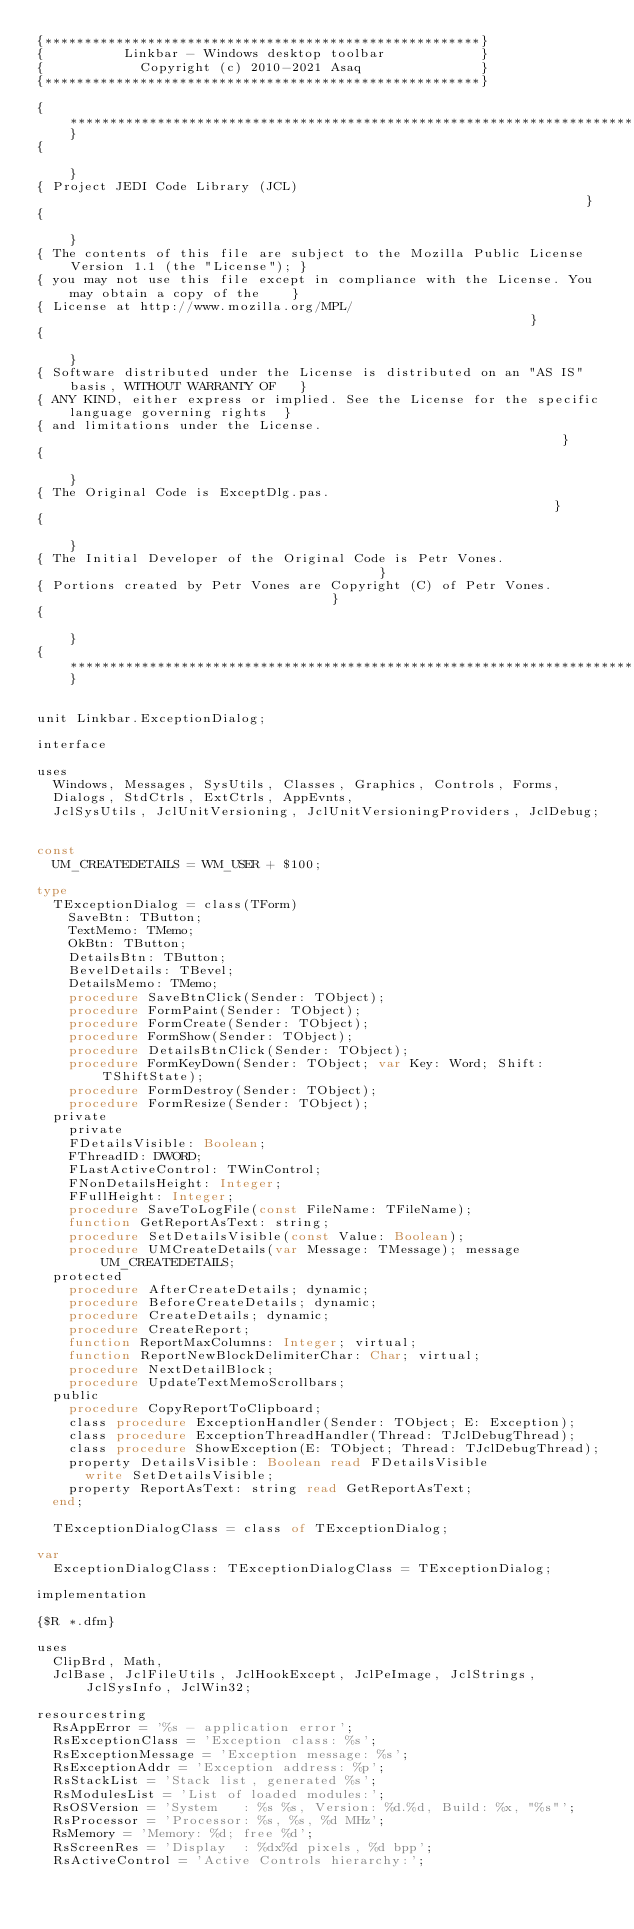<code> <loc_0><loc_0><loc_500><loc_500><_Pascal_>{*******************************************************}
{          Linkbar - Windows desktop toolbar            }
{            Copyright (c) 2010-2021 Asaq               }
{*******************************************************}

{**************************************************************************************************}
{                                                                                                  }
{ Project JEDI Code Library (JCL)                                                                  }
{                                                                                                  }
{ The contents of this file are subject to the Mozilla Public License Version 1.1 (the "License"); }
{ you may not use this file except in compliance with the License. You may obtain a copy of the    }
{ License at http://www.mozilla.org/MPL/                                                           }
{                                                                                                  }
{ Software distributed under the License is distributed on an "AS IS" basis, WITHOUT WARRANTY OF   }
{ ANY KIND, either express or implied. See the License for the specific language governing rights  }
{ and limitations under the License.                                                               }
{                                                                                                  }
{ The Original Code is ExceptDlg.pas.                                                              }
{                                                                                                  }
{ The Initial Developer of the Original Code is Petr Vones.                                        }
{ Portions created by Petr Vones are Copyright (C) of Petr Vones.                                  }
{                                                                                                  }
{**************************************************************************************************}


unit Linkbar.ExceptionDialog;

interface

uses
  Windows, Messages, SysUtils, Classes, Graphics, Controls, Forms,
  Dialogs, StdCtrls, ExtCtrls, AppEvnts,
  JclSysUtils, JclUnitVersioning, JclUnitVersioningProviders, JclDebug;


const
  UM_CREATEDETAILS = WM_USER + $100;

type
  TExceptionDialog = class(TForm)
    SaveBtn: TButton;
    TextMemo: TMemo;
    OkBtn: TButton;
    DetailsBtn: TButton;
    BevelDetails: TBevel;
    DetailsMemo: TMemo;
    procedure SaveBtnClick(Sender: TObject);
    procedure FormPaint(Sender: TObject);
    procedure FormCreate(Sender: TObject);
    procedure FormShow(Sender: TObject);
    procedure DetailsBtnClick(Sender: TObject);
    procedure FormKeyDown(Sender: TObject; var Key: Word; Shift: TShiftState);
    procedure FormDestroy(Sender: TObject);
    procedure FormResize(Sender: TObject);
  private
    private
    FDetailsVisible: Boolean;
    FThreadID: DWORD;
    FLastActiveControl: TWinControl;
    FNonDetailsHeight: Integer;
    FFullHeight: Integer;
    procedure SaveToLogFile(const FileName: TFileName);
    function GetReportAsText: string;
    procedure SetDetailsVisible(const Value: Boolean);
    procedure UMCreateDetails(var Message: TMessage); message UM_CREATEDETAILS;
  protected
    procedure AfterCreateDetails; dynamic;
    procedure BeforeCreateDetails; dynamic;
    procedure CreateDetails; dynamic;
    procedure CreateReport;
    function ReportMaxColumns: Integer; virtual;
    function ReportNewBlockDelimiterChar: Char; virtual;
    procedure NextDetailBlock;
    procedure UpdateTextMemoScrollbars;
  public
    procedure CopyReportToClipboard;
    class procedure ExceptionHandler(Sender: TObject; E: Exception);
    class procedure ExceptionThreadHandler(Thread: TJclDebugThread);
    class procedure ShowException(E: TObject; Thread: TJclDebugThread);
    property DetailsVisible: Boolean read FDetailsVisible
      write SetDetailsVisible;
    property ReportAsText: string read GetReportAsText;
  end;

  TExceptionDialogClass = class of TExceptionDialog;

var
  ExceptionDialogClass: TExceptionDialogClass = TExceptionDialog;

implementation

{$R *.dfm}

uses
  ClipBrd, Math,
  JclBase, JclFileUtils, JclHookExcept, JclPeImage, JclStrings, JclSysInfo, JclWin32;

resourcestring
  RsAppError = '%s - application error';
  RsExceptionClass = 'Exception class: %s';
  RsExceptionMessage = 'Exception message: %s';
  RsExceptionAddr = 'Exception address: %p';
  RsStackList = 'Stack list, generated %s';
  RsModulesList = 'List of loaded modules:';
  RsOSVersion = 'System   : %s %s, Version: %d.%d, Build: %x, "%s"';
  RsProcessor = 'Processor: %s, %s, %d MHz';
  RsMemory = 'Memory: %d; free %d';
  RsScreenRes = 'Display  : %dx%d pixels, %d bpp';
  RsActiveControl = 'Active Controls hierarchy:';</code> 